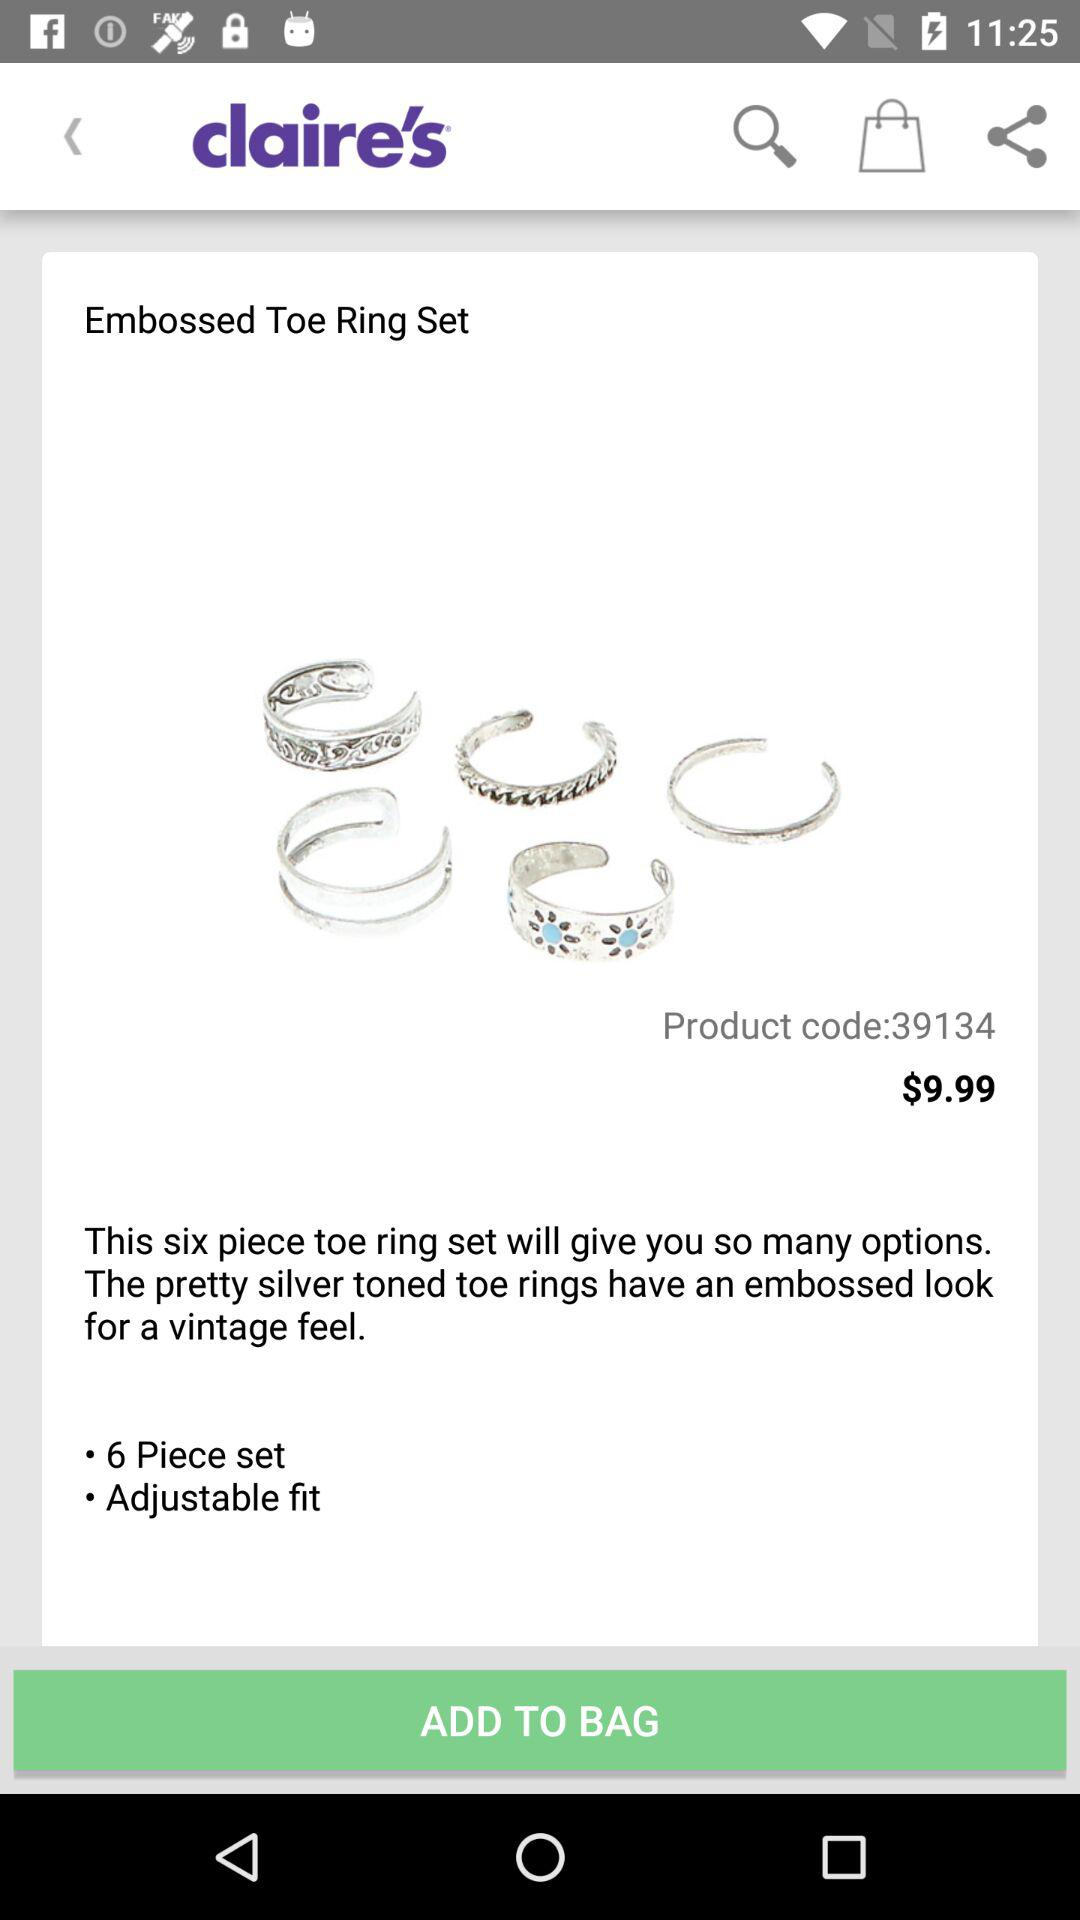What is the product code? The product code is 39134. 